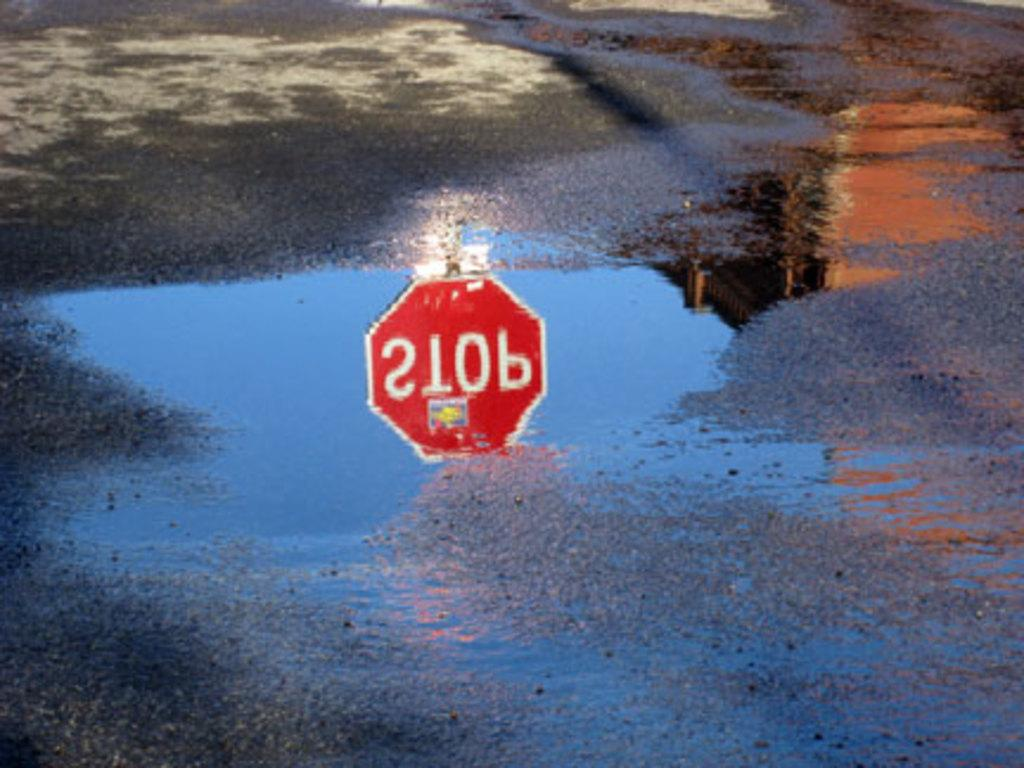<image>
Share a concise interpretation of the image provided. a stop sign that is reflected in the water 